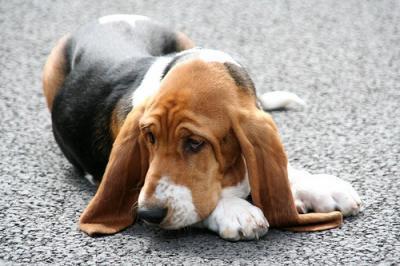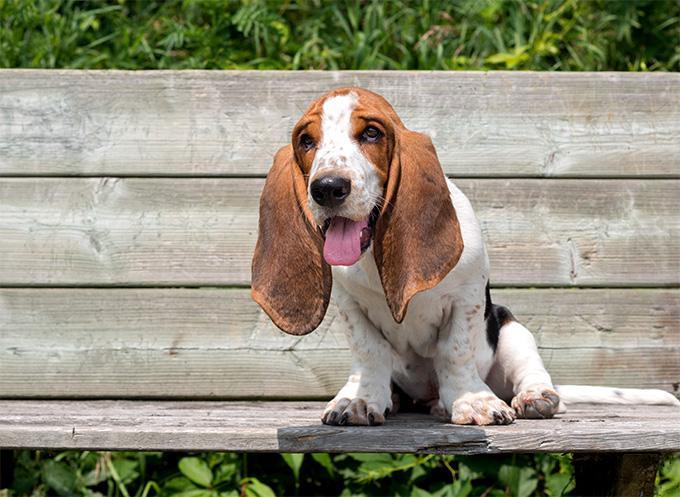The first image is the image on the left, the second image is the image on the right. For the images displayed, is the sentence "There are at least seven dogs." factually correct? Answer yes or no. No. 